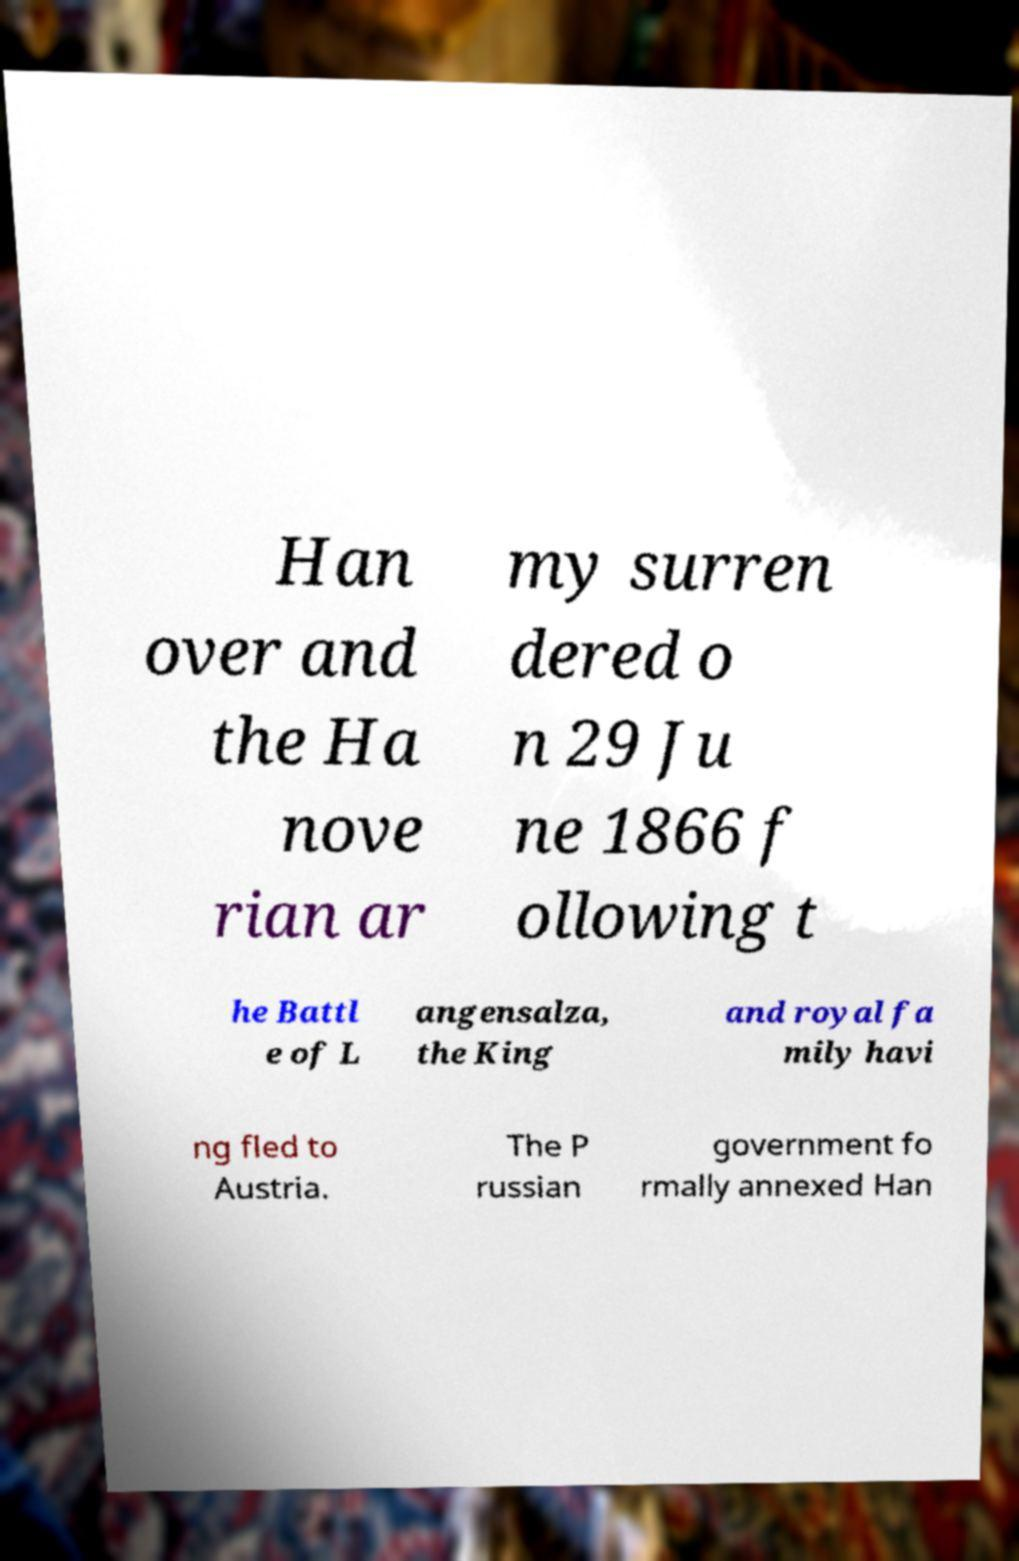Please read and relay the text visible in this image. What does it say? Han over and the Ha nove rian ar my surren dered o n 29 Ju ne 1866 f ollowing t he Battl e of L angensalza, the King and royal fa mily havi ng fled to Austria. The P russian government fo rmally annexed Han 